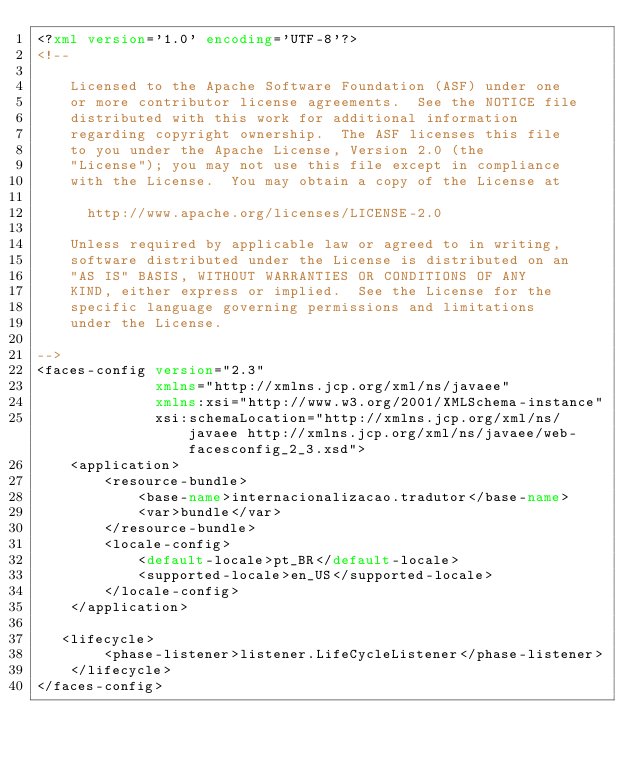<code> <loc_0><loc_0><loc_500><loc_500><_XML_><?xml version='1.0' encoding='UTF-8'?>
<!--

    Licensed to the Apache Software Foundation (ASF) under one
    or more contributor license agreements.  See the NOTICE file
    distributed with this work for additional information
    regarding copyright ownership.  The ASF licenses this file
    to you under the Apache License, Version 2.0 (the
    "License"); you may not use this file except in compliance
    with the License.  You may obtain a copy of the License at

      http://www.apache.org/licenses/LICENSE-2.0

    Unless required by applicable law or agreed to in writing,
    software distributed under the License is distributed on an
    "AS IS" BASIS, WITHOUT WARRANTIES OR CONDITIONS OF ANY
    KIND, either express or implied.  See the License for the
    specific language governing permissions and limitations
    under the License.

-->
<faces-config version="2.3"
              xmlns="http://xmlns.jcp.org/xml/ns/javaee"
              xmlns:xsi="http://www.w3.org/2001/XMLSchema-instance"
              xsi:schemaLocation="http://xmlns.jcp.org/xml/ns/javaee http://xmlns.jcp.org/xml/ns/javaee/web-facesconfig_2_3.xsd">
    <application>
        <resource-bundle>
            <base-name>internacionalizacao.tradutor</base-name>
            <var>bundle</var>
        </resource-bundle>
        <locale-config>
            <default-locale>pt_BR</default-locale>
            <supported-locale>en_US</supported-locale>
        </locale-config>
    </application>
    
   <lifecycle>
        <phase-listener>listener.LifeCycleListener</phase-listener>
    </lifecycle>
</faces-config>
</code> 